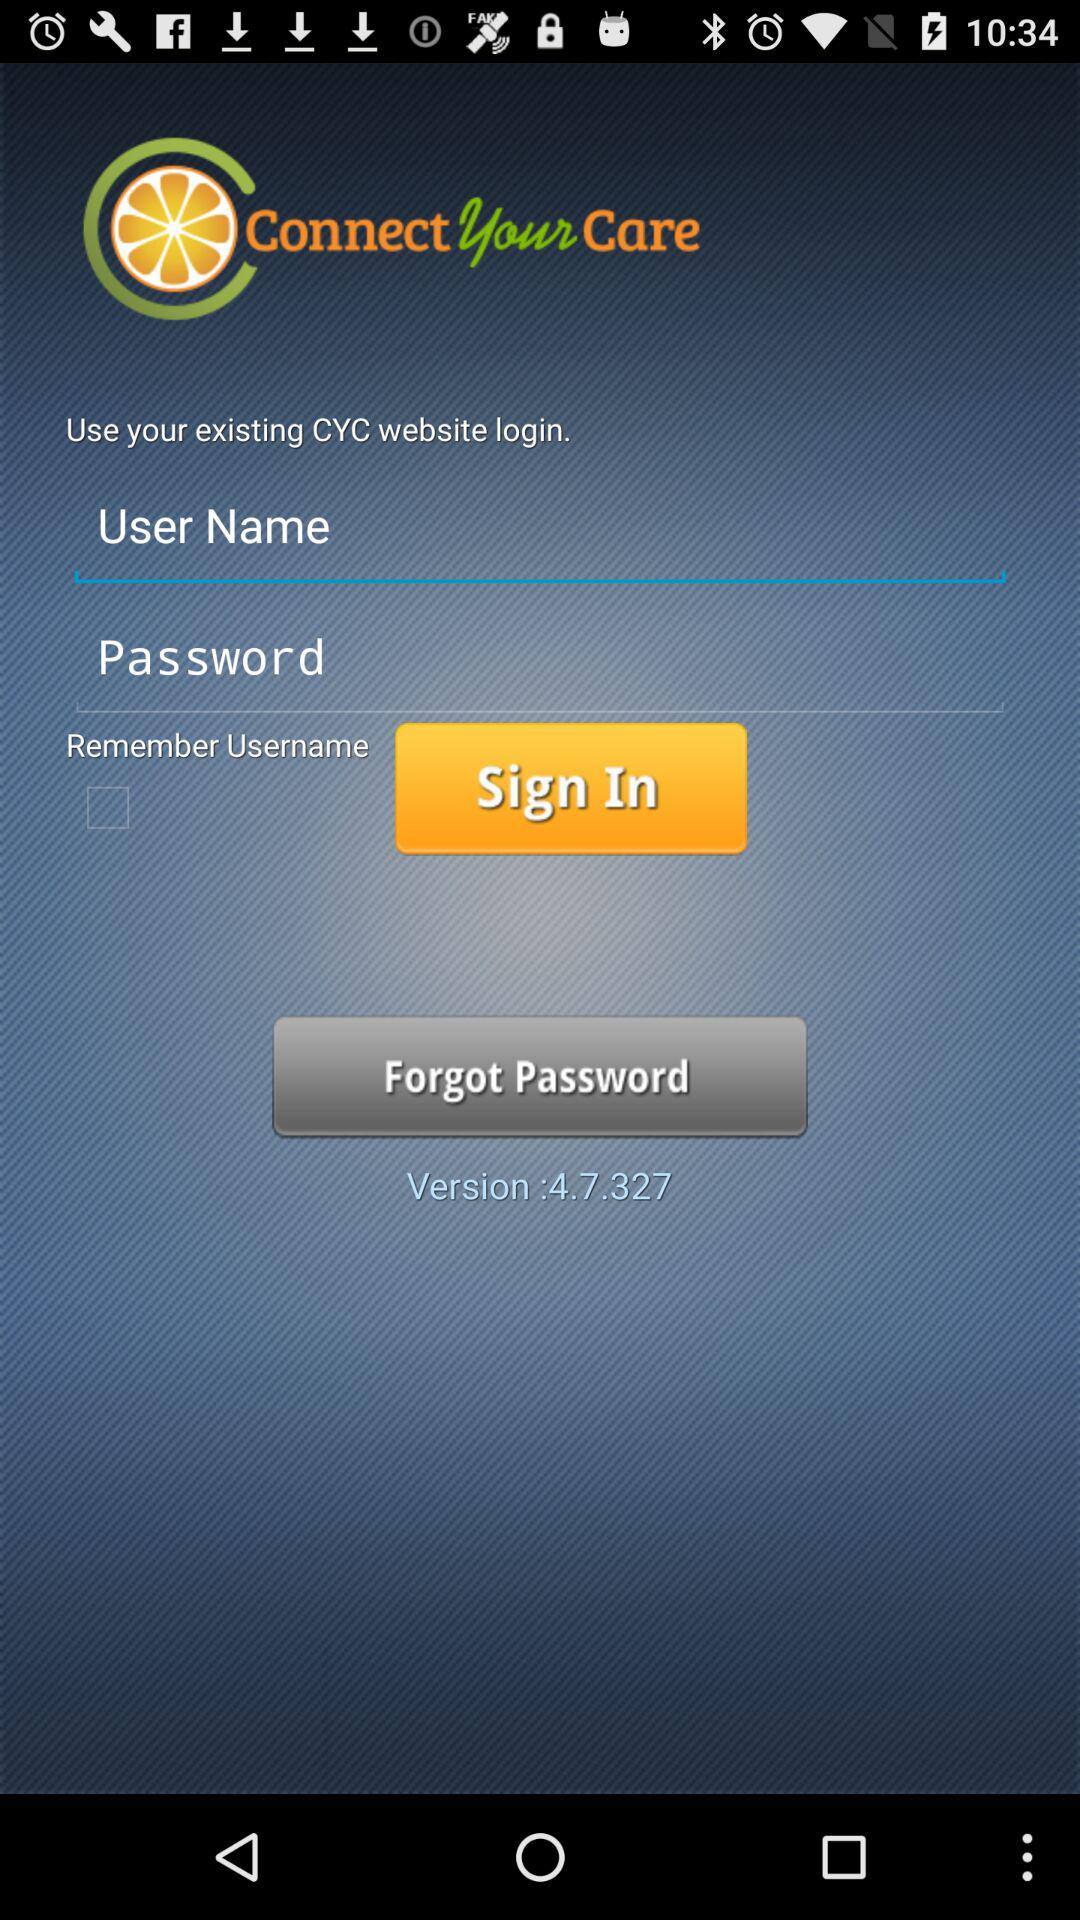What is the status of the "Remember Username"? The status is "off". 